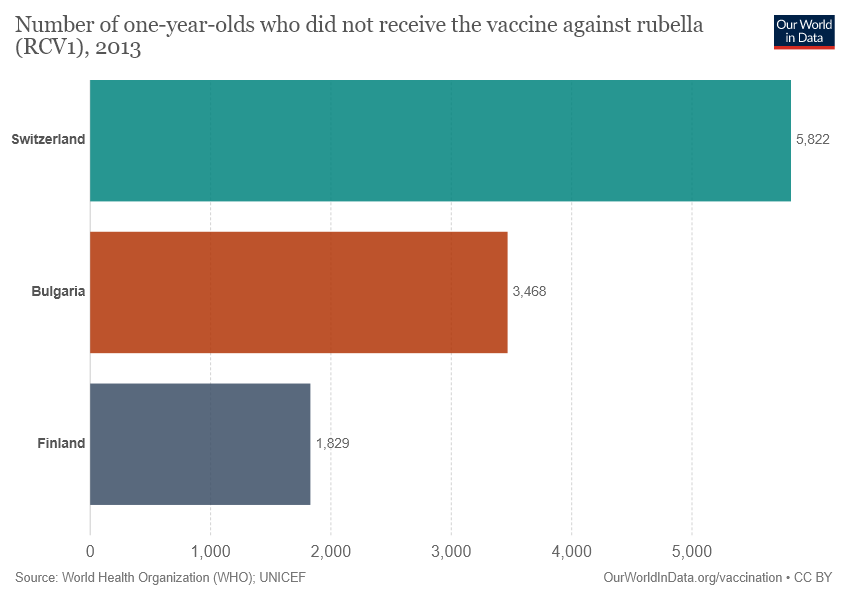Highlight a few significant elements in this photo. The lowest value in the graph is 1829. The difference between the highest and the lowest value is greater than the middle bar value. 